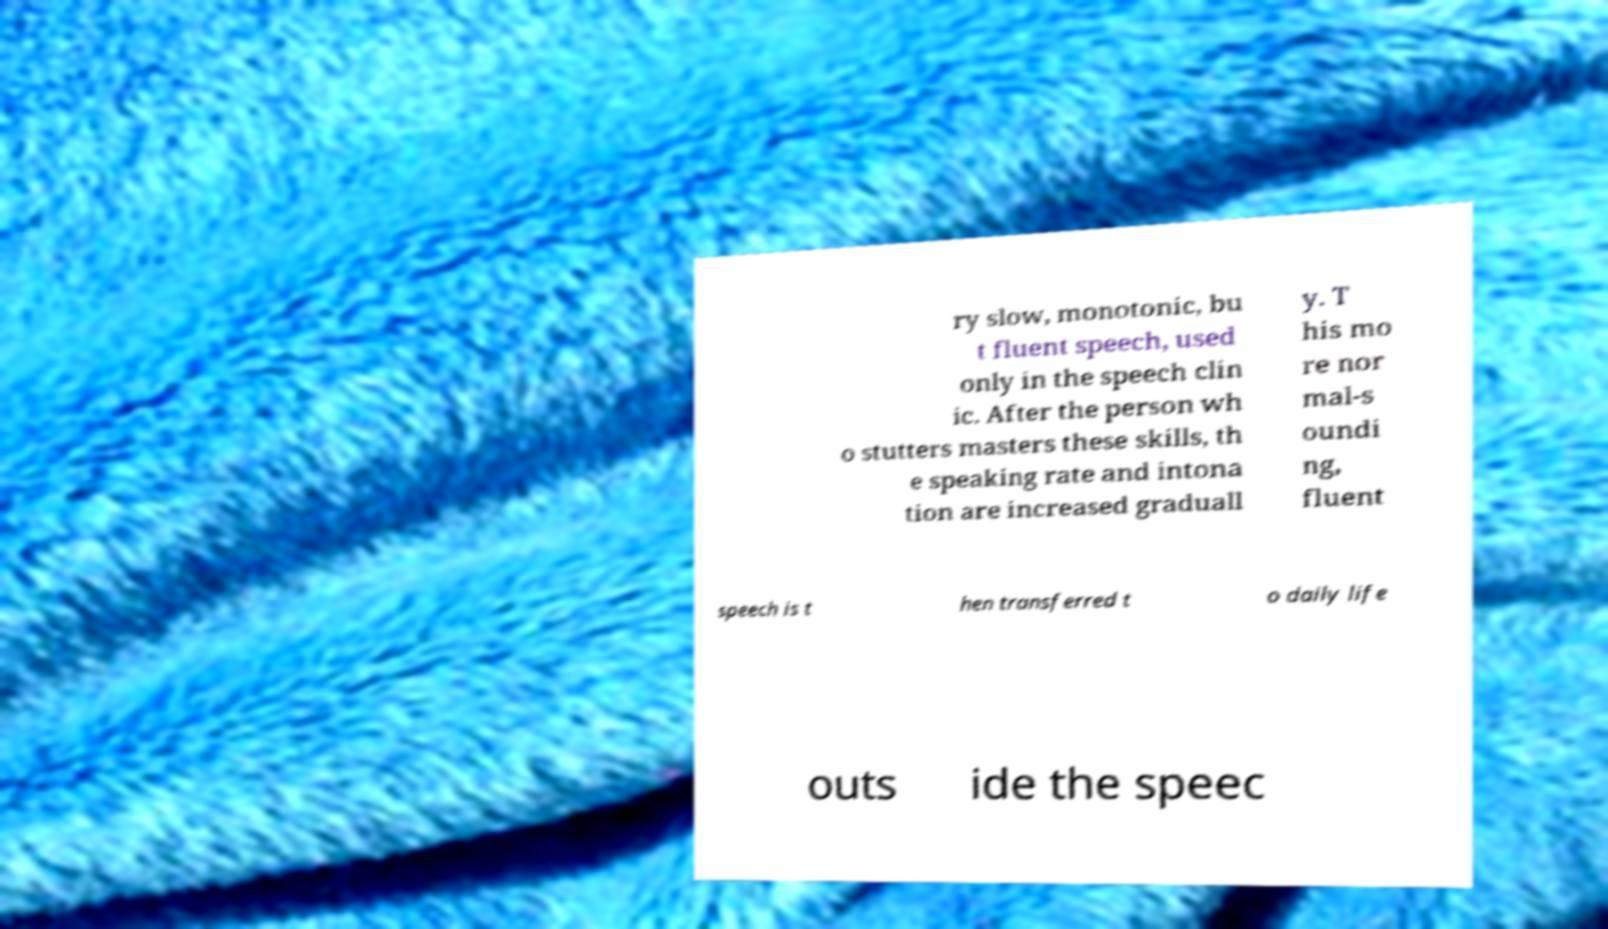What messages or text are displayed in this image? I need them in a readable, typed format. ry slow, monotonic, bu t fluent speech, used only in the speech clin ic. After the person wh o stutters masters these skills, th e speaking rate and intona tion are increased graduall y. T his mo re nor mal-s oundi ng, fluent speech is t hen transferred t o daily life outs ide the speec 